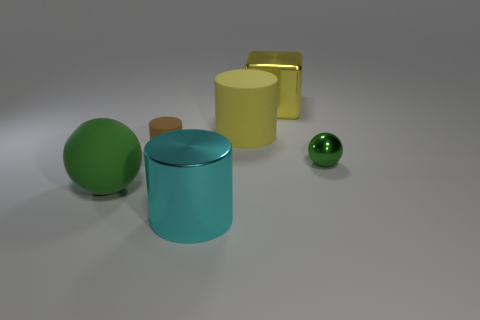What is the shape of the large object that is the same color as the tiny metal object?
Your response must be concise. Sphere. Are there fewer objects in front of the tiny matte cylinder than big yellow metallic cubes?
Ensure brevity in your answer.  No. Is the size of the green sphere that is on the right side of the green matte thing the same as the brown rubber object?
Offer a very short reply. Yes. What number of big metallic things are the same shape as the tiny green metallic object?
Your answer should be compact. 0. There is a brown thing that is made of the same material as the big ball; what is its size?
Make the answer very short. Small. Is the number of green rubber things that are left of the green rubber object the same as the number of big brown cubes?
Give a very brief answer. Yes. Does the tiny shiny sphere have the same color as the large rubber ball?
Provide a short and direct response. Yes. Does the big rubber object right of the large cyan metallic object have the same shape as the green object to the right of the yellow cylinder?
Ensure brevity in your answer.  No. What is the material of the big thing that is the same shape as the tiny green metallic object?
Give a very brief answer. Rubber. The cylinder that is behind the green matte object and on the right side of the small brown object is what color?
Offer a terse response. Yellow. 